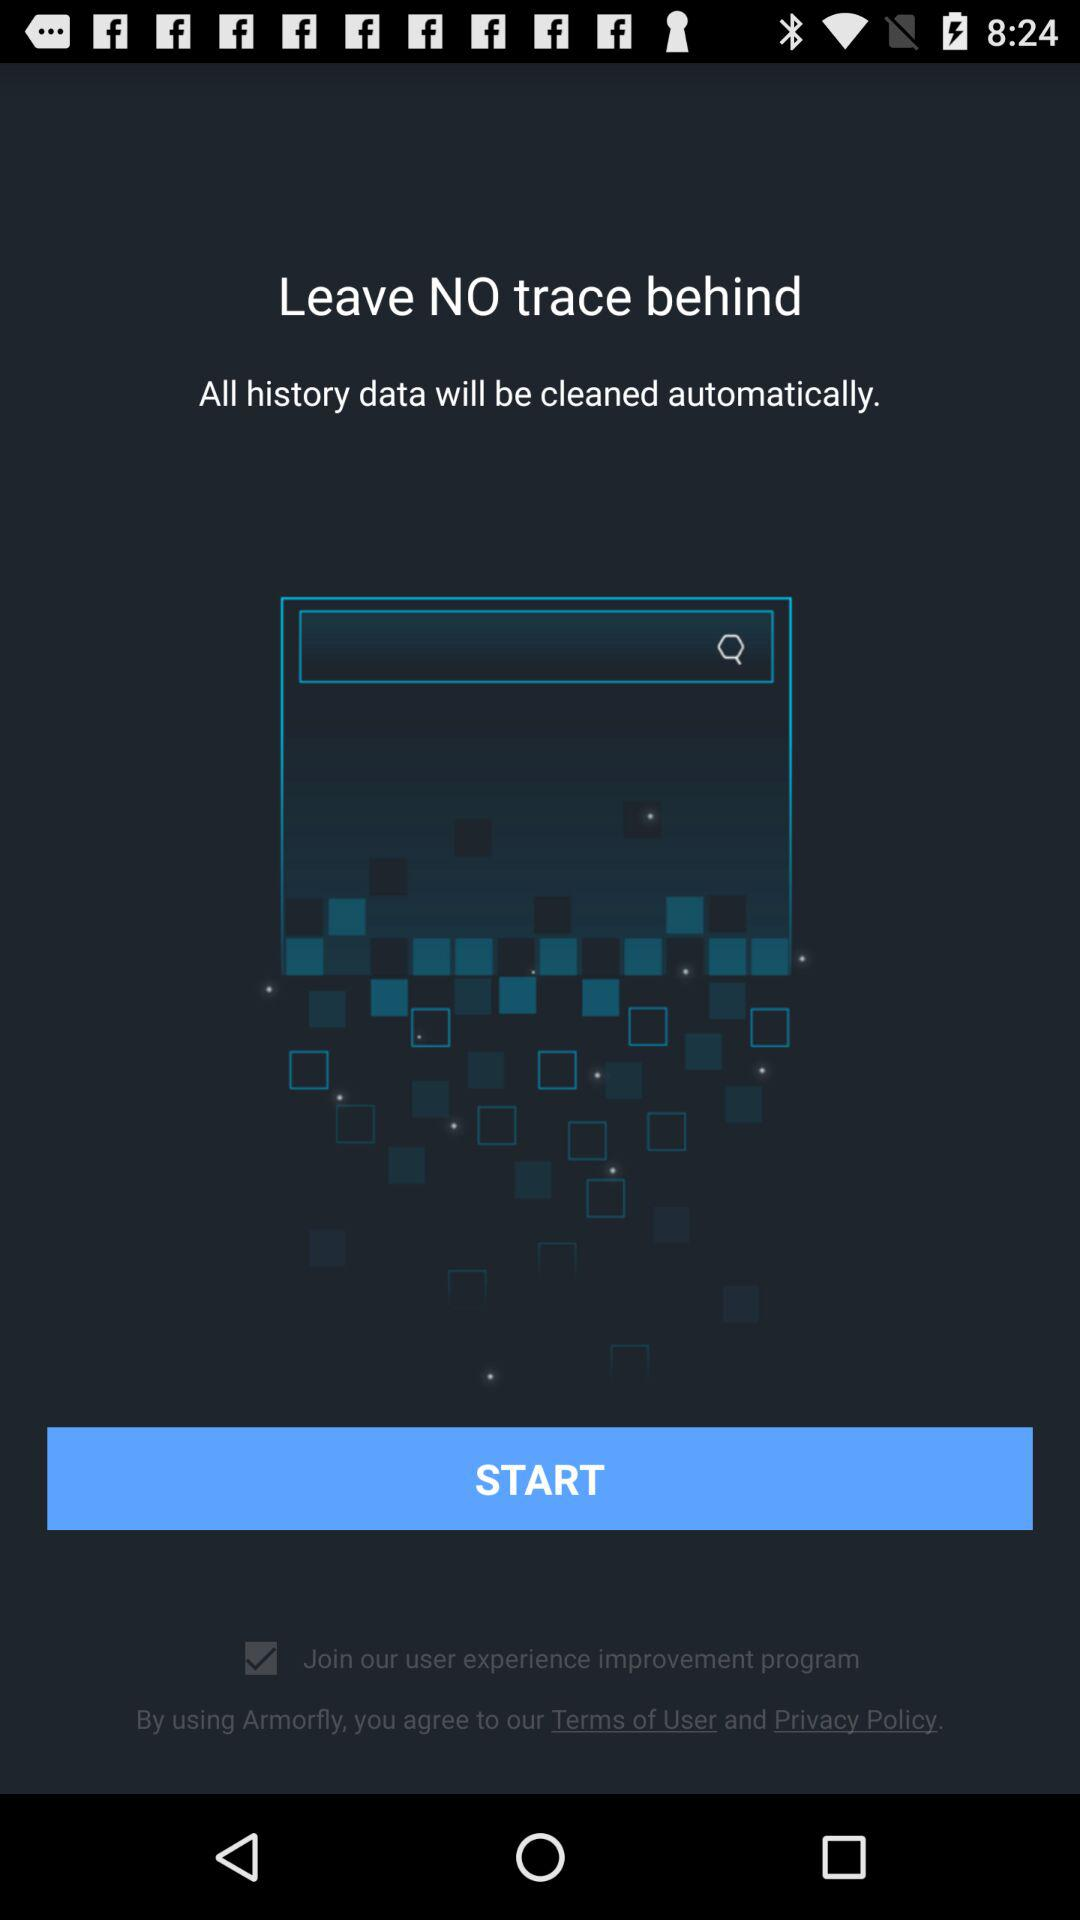What is the name of the application? The application name is "Armorfly". 